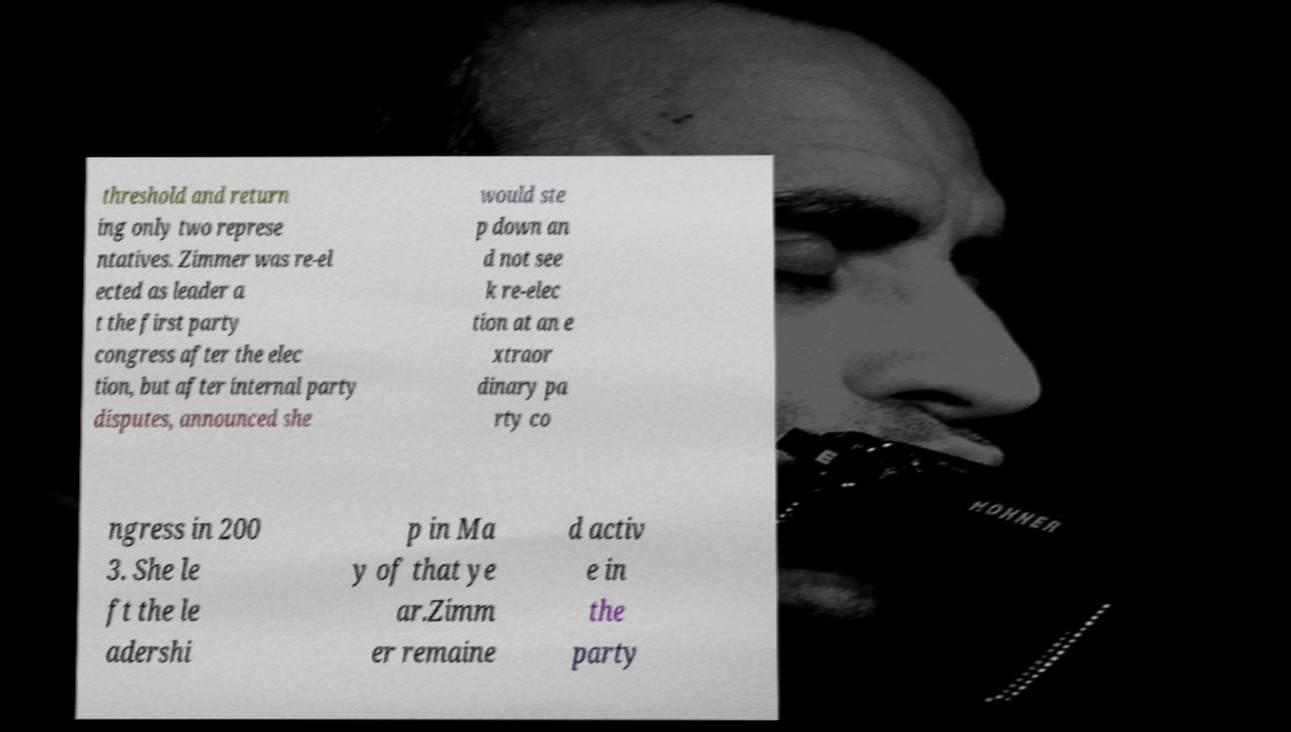There's text embedded in this image that I need extracted. Can you transcribe it verbatim? threshold and return ing only two represe ntatives. Zimmer was re-el ected as leader a t the first party congress after the elec tion, but after internal party disputes, announced she would ste p down an d not see k re-elec tion at an e xtraor dinary pa rty co ngress in 200 3. She le ft the le adershi p in Ma y of that ye ar.Zimm er remaine d activ e in the party 